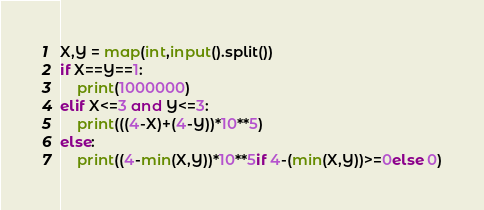Convert code to text. <code><loc_0><loc_0><loc_500><loc_500><_Python_>X,Y = map(int,input().split())
if X==Y==1:
    print(1000000)
elif X<=3 and Y<=3:
    print(((4-X)+(4-Y))*10**5)
else:
    print((4-min(X,Y))*10**5if 4-(min(X,Y))>=0else 0)</code> 